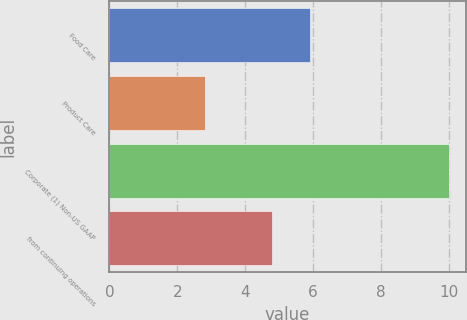<chart> <loc_0><loc_0><loc_500><loc_500><bar_chart><fcel>Food Care<fcel>Product Care<fcel>Corporate (1) Non-US GAAP<fcel>from continuing operations<nl><fcel>5.9<fcel>2.8<fcel>10<fcel>4.8<nl></chart> 